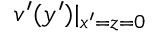Convert formula to latex. <formula><loc_0><loc_0><loc_500><loc_500>v ^ { \prime } ( y ^ { \prime } ) | _ { x ^ { \prime } = z = 0 }</formula> 